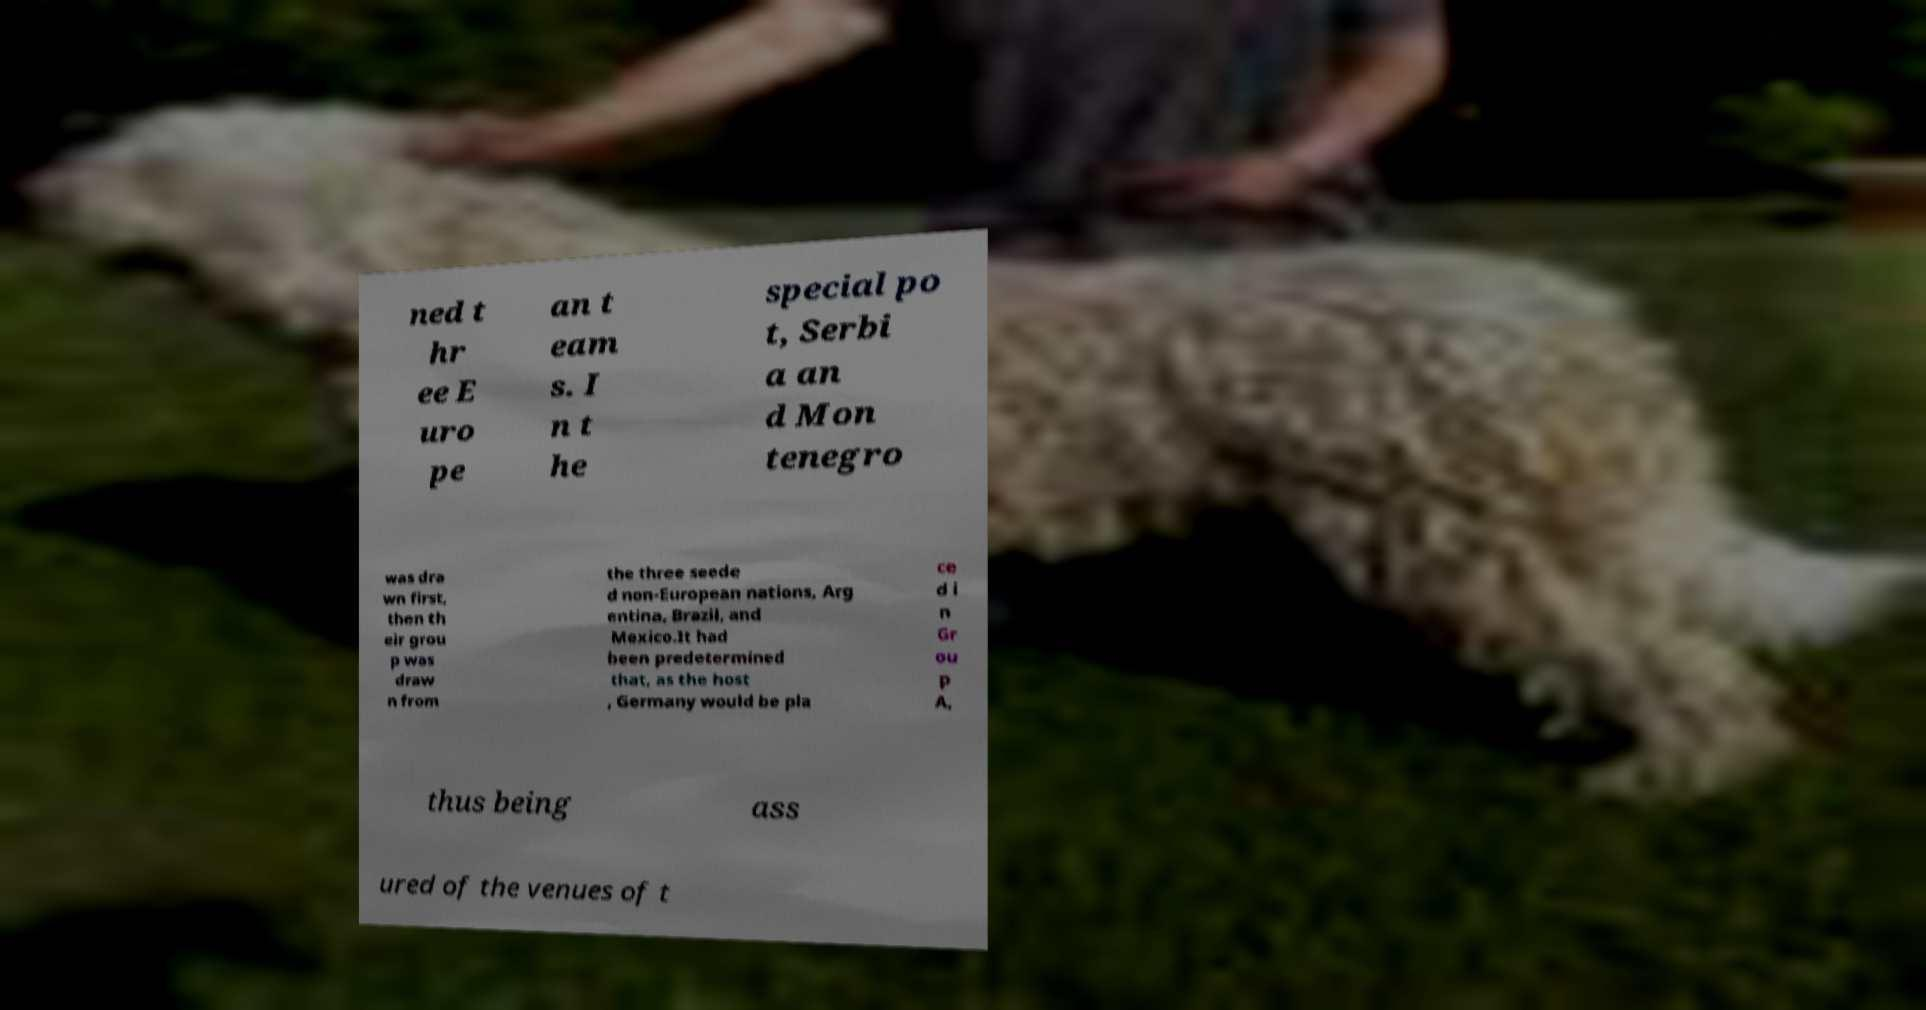For documentation purposes, I need the text within this image transcribed. Could you provide that? ned t hr ee E uro pe an t eam s. I n t he special po t, Serbi a an d Mon tenegro was dra wn first, then th eir grou p was draw n from the three seede d non-European nations, Arg entina, Brazil, and Mexico.It had been predetermined that, as the host , Germany would be pla ce d i n Gr ou p A, thus being ass ured of the venues of t 